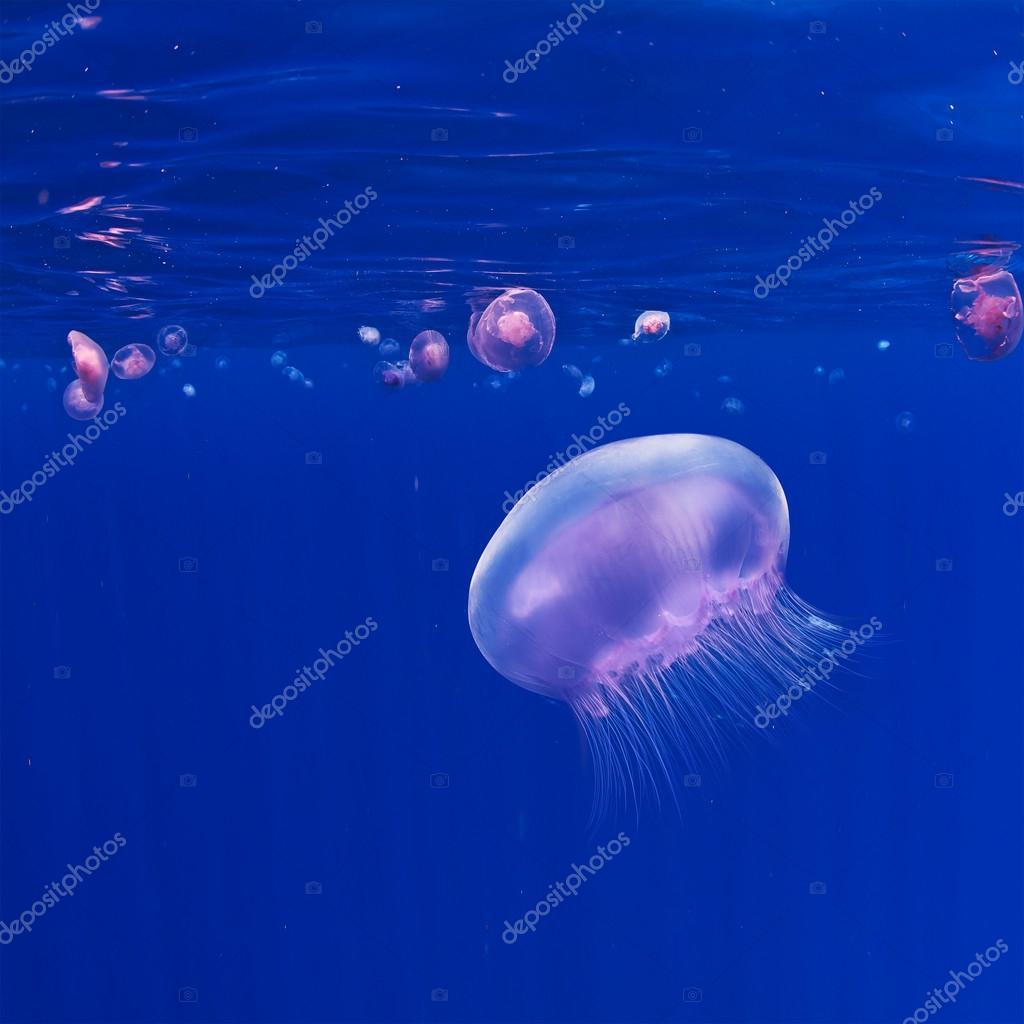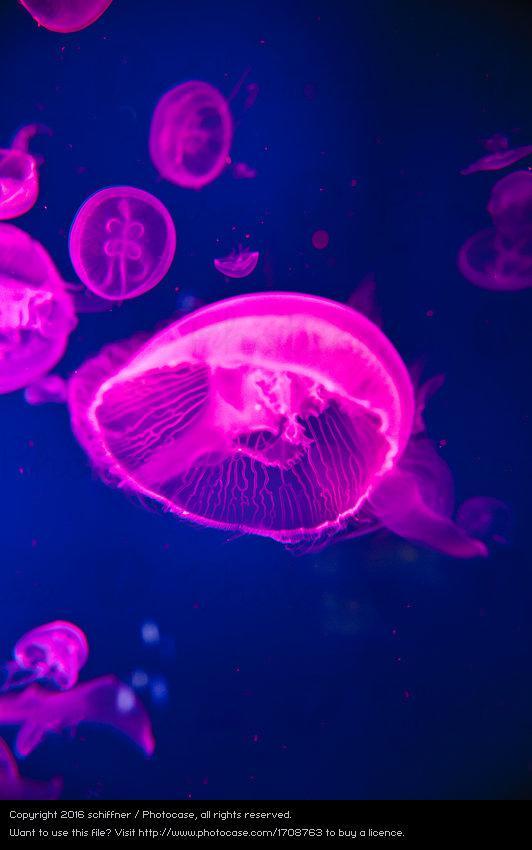The first image is the image on the left, the second image is the image on the right. Analyze the images presented: Is the assertion "At least one jellyfish has tentacles longer than its body." valid? Answer yes or no. No. The first image is the image on the left, the second image is the image on the right. For the images displayed, is the sentence "Neon pink jellyfish are shown in the right image." factually correct? Answer yes or no. Yes. 